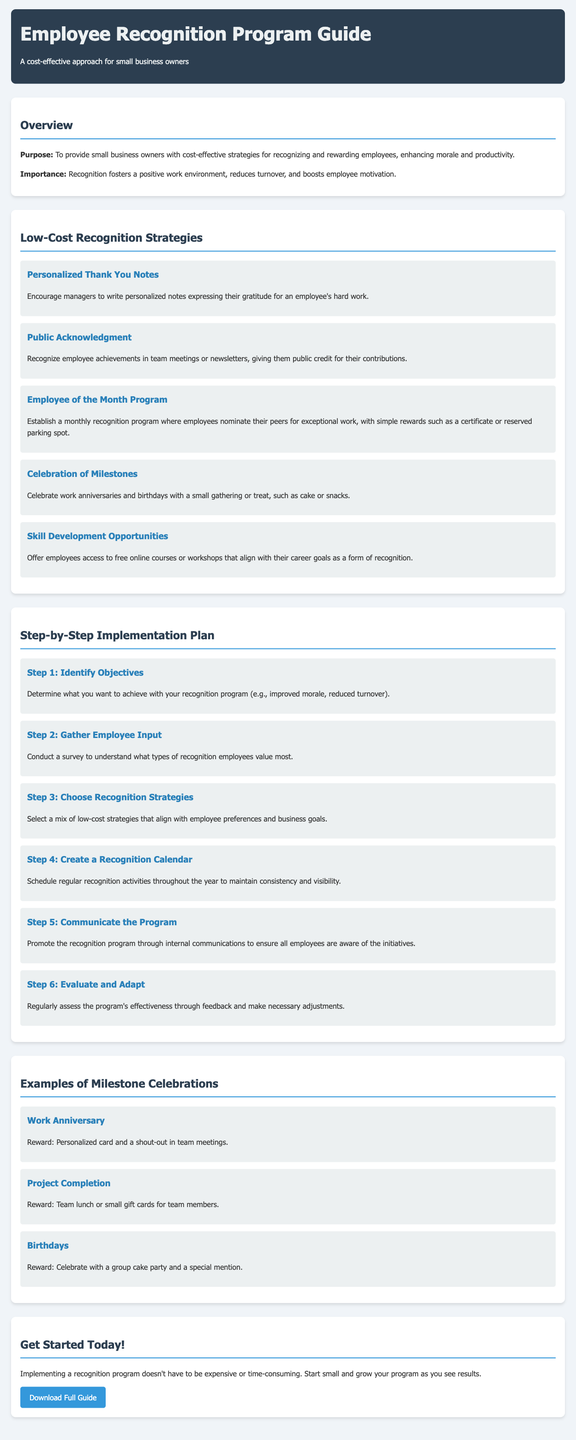what is the primary purpose of the Employee Recognition Program Guide? The primary purpose is to provide small business owners with cost-effective strategies for recognizing and rewarding employees, enhancing morale and productivity.
Answer: cost-effective strategies what is an example of a low-cost recognition strategy mentioned in the guide? The guide lists several strategies, one of which is the Employee of the Month Program that encourages peer nominations.
Answer: Employee of the Month Program how many steps are included in the implementation plan for the recognition program? The guide outlines a total of six specific steps for implementing the recognition program.
Answer: six what type of reward is suggested for celebrating work anniversaries? The suggestion for work anniversaries includes a personalized card and a shout-out in team meetings.
Answer: personalized card and a shout-out what is the first step in the step-by-step implementation plan? The first step is to identify objectives for what the recognition program aims to achieve.
Answer: Identify Objectives how should feedback be used in the recognition program according to the guide? Feedback should be regularly assessed to evaluate the program's effectiveness and make necessary adjustments.
Answer: evaluate and adapt what is one way to gather employee input for the recognition program? The guide suggests conducting a survey to understand the types of recognition that employees value most.
Answer: conduct a survey what type of celebration is suggested for project completion? For project completion, it is suggested to have a team lunch or provide small gift cards for team members.
Answer: team lunch or small gift cards 